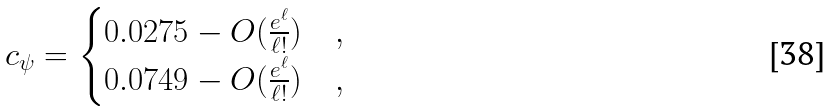Convert formula to latex. <formula><loc_0><loc_0><loc_500><loc_500>c _ { \psi } = \begin{cases} 0 . 0 2 7 5 - O ( \frac { e ^ { \ell } } { \ell ! } ) & , \\ 0 . 0 7 4 9 - O ( \frac { e ^ { \ell } } { \ell ! } ) & , \end{cases}</formula> 